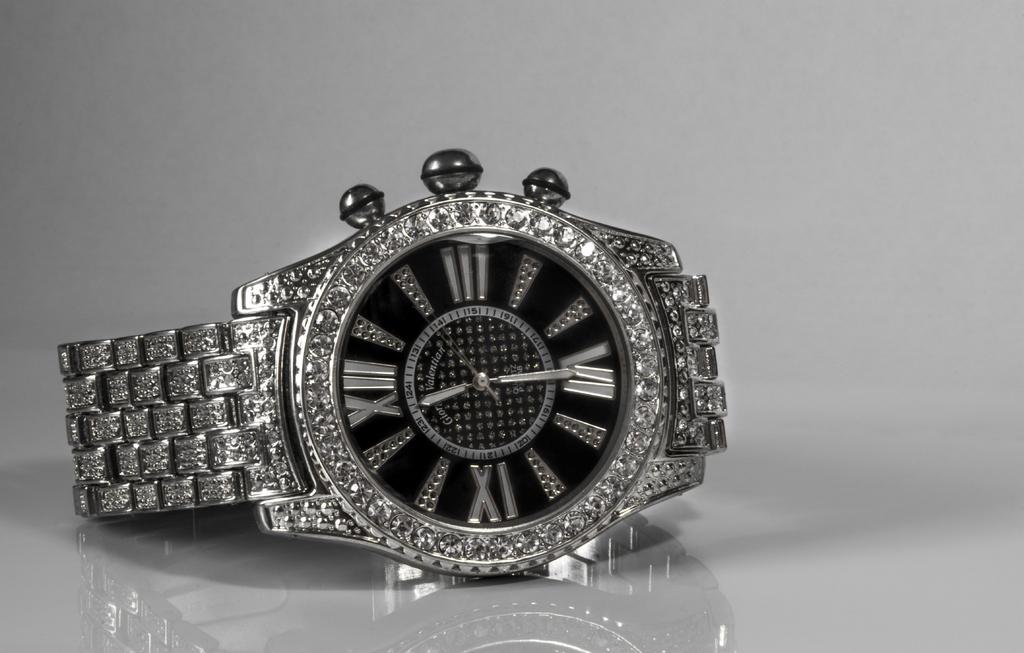What kind of numbers are shown?
Offer a terse response. Roman numerals. 